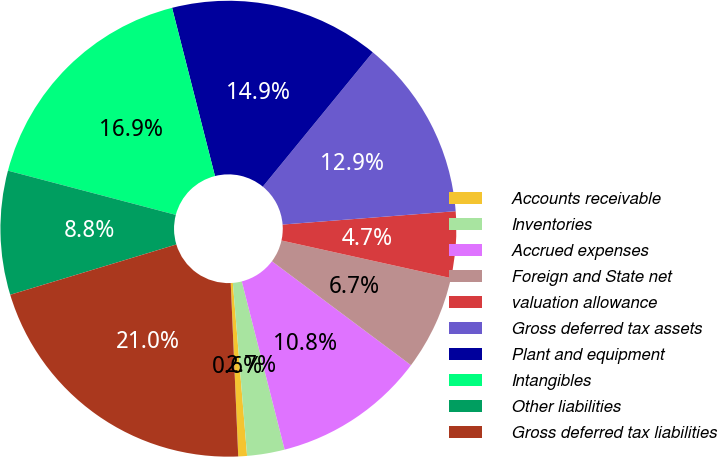Convert chart. <chart><loc_0><loc_0><loc_500><loc_500><pie_chart><fcel>Accounts receivable<fcel>Inventories<fcel>Accrued expenses<fcel>Foreign and State net<fcel>valuation allowance<fcel>Gross deferred tax assets<fcel>Plant and equipment<fcel>Intangibles<fcel>Other liabilities<fcel>Gross deferred tax liabilities<nl><fcel>0.62%<fcel>2.66%<fcel>10.82%<fcel>6.74%<fcel>4.7%<fcel>12.86%<fcel>14.89%<fcel>16.93%<fcel>8.78%<fcel>21.01%<nl></chart> 